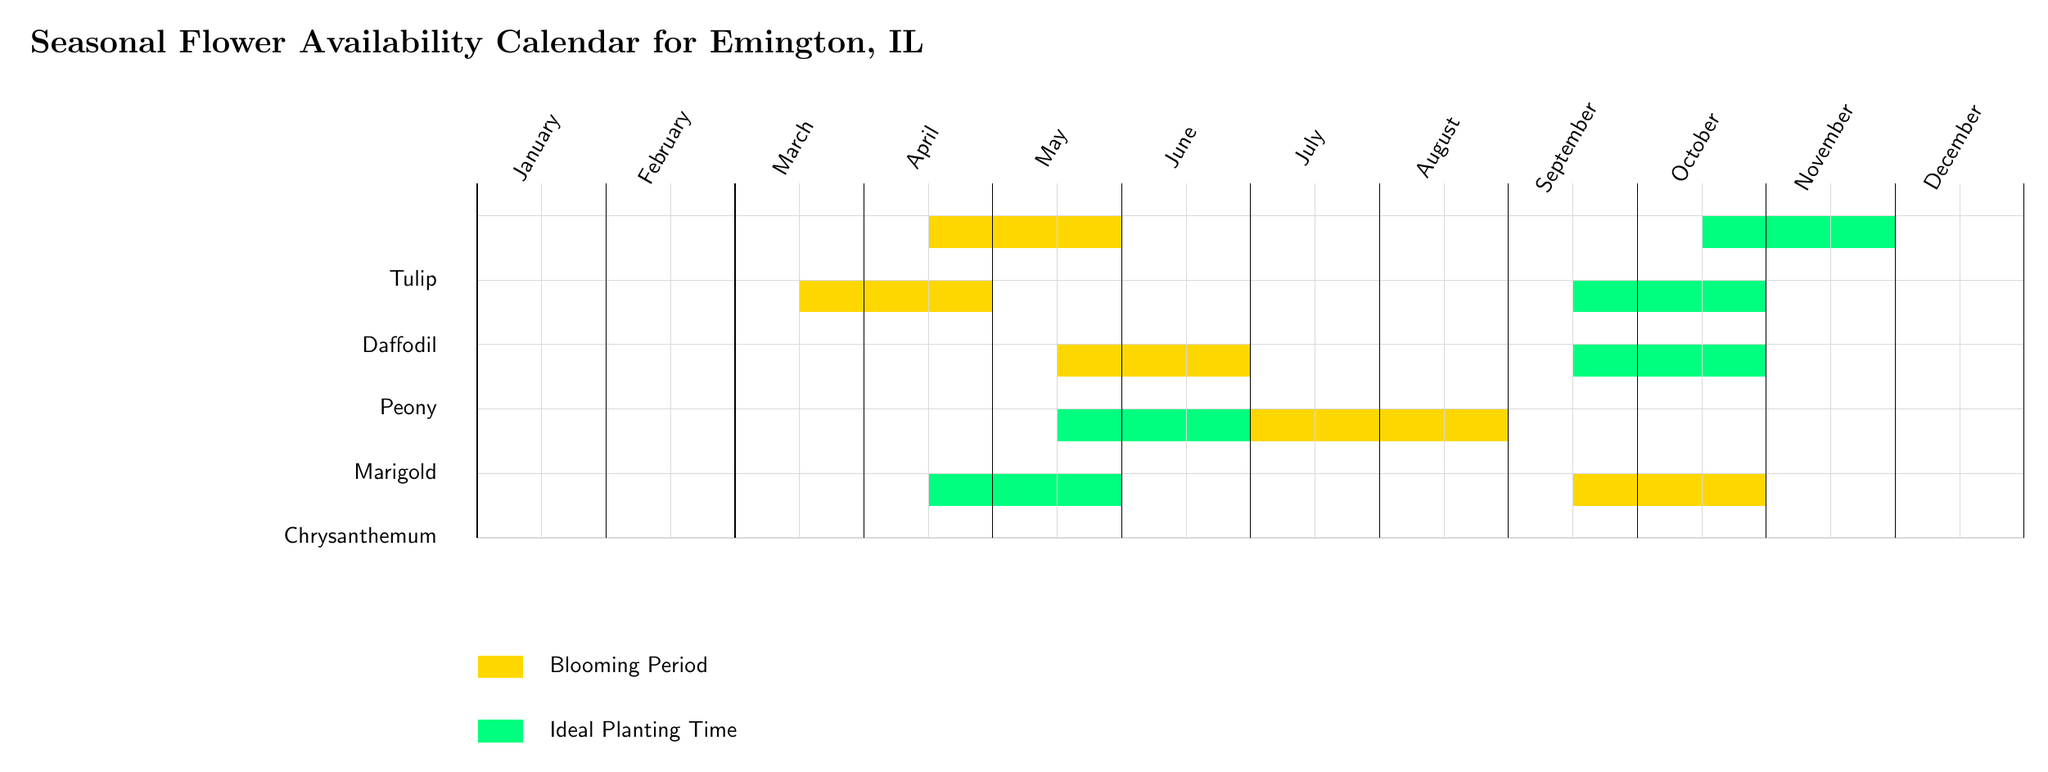What month do tulips bloom? The diagram shows a rectangular highlight for tulips from the 7th month to the 10th month, indicating their blooming period. Therefore, tulips bloom in April through June.
Answer: April to June What is the ideal planting time for Chrysanthemums? The diagram indicates a rectangle for the ideal planting time of Chrysanthemums, which spans from the 7th month to the 10th month. This shows that they should be planted in June through September.
Answer: June to September How many flowers are represented in the diagram? By counting the flower names listed on the left side of the diagram, there are five types of flowers: Tulip, Daffodil, Peony, Marigold, and Chrysanthemum.
Answer: Five Which flowers bloom in May? Looking at the blooming period rectangles for each flower, both Peonies and Marigolds have their blooming periods during May.
Answer: Peony and Marigold When should Daffodils be planted? The planting period for Daffodils is indicated in the diagram from the 5th month to the 8th month. Thus, Daffodils should be planted starting in May and extending through July.
Answer: May to July How does the blooming period of Marigolds compare to Peonies? The diagram reveals that Marigolds bloom from May to August, while Peonies bloom from April to June. This allows us to see that the blooming periods partially overlap in May and June and that Marigolds bloom for a longer duration.
Answer: Both overlap in May and June; Marigolds bloom longer In which month do you plant Peonies? The diagram illustrates that the ideal planting time for Peonies is from the 5th month to the 8th month. Therefore, Peonies should ideally be planted from May to August.
Answer: May to August 